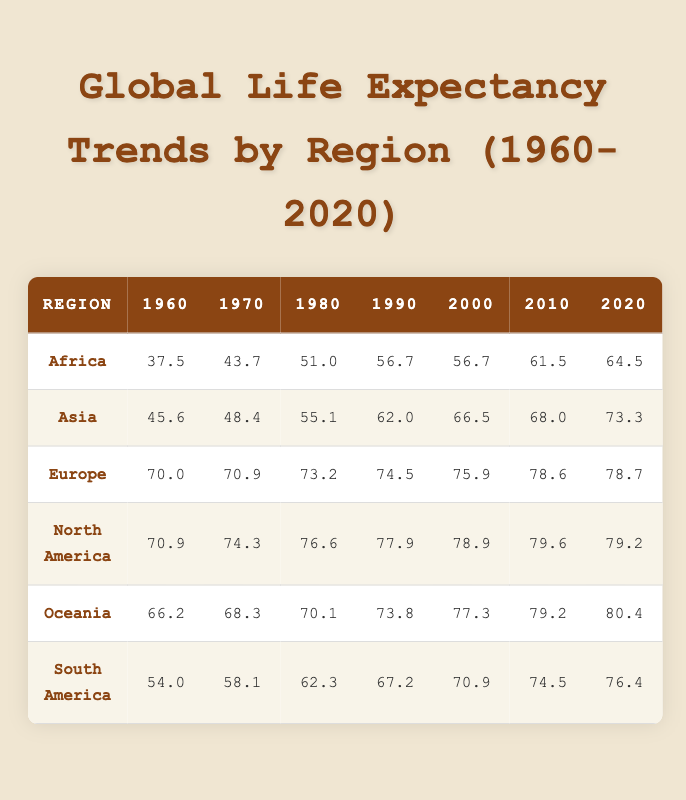What was the life expectancy in Africa in 1960? The table indicates that in 1960, the life expectancy in Africa was 37.5 years, directly available in the first column under the Africa row.
Answer: 37.5 Which region had the highest life expectancy in 1980? In 1980, the table shows that North America had the highest life expectancy at 76.6 years, which is the maximum value in that year’s row.
Answer: North America: 76.6 What is the difference in life expectancy between Europe in 1960 and Europe in 2020? Europe's life expectancy in 1960 was 70.0 years and in 2020 it was 78.7 years. The difference is 78.7 - 70.0 = 8.7 years.
Answer: 8.7 Did life expectancy in Oceania increase every decade from 1960 to 2020? Reviewing the table, Oceania had life expectancies of 66.2, 68.3, 70.1, 73.8, 77.3, 79.2, and 80.4 for the respective years. Since each value is higher than the previous one, we can conclude life expectancy increased consistently.
Answer: Yes What was the average life expectancy in Asia from 1960 to 2020? For Asia, the values are as follows: 45.6 (1960), 48.4 (1970), 55.1 (1980), 62.0 (1990), 66.5 (2000), 68.0 (2010), and 73.3 (2020). The total is 45.6 + 48.4 + 55.1 + 62.0 + 66.5 + 68.0 + 73.3 = 419.9. The average is 419.9 / 7 ≈ 59.99.
Answer: 59.99 In which year did South America first exceed a life expectancy of 70 years? The table shows that South America's life expectancy was 70.9 years in 2000, marking the first instance it exceeded 70. Prior values in 1960, 1970, 1980, and 1990 were below this threshold.
Answer: 2000 Which region showed the smallest increase in life expectancy from 2010 to 2020? In 2010, North America had a life expectancy of 79.6 years and in 2020 it was 79.2 years, indicating a decrease of 0.4 years. Meanwhile, Africa increased by 3.0 years. Therefore, North America had the smallest change.
Answer: North America How much did life expectancy in Africa improve from 1960 to 2020? The life expectancy in Africa improved from 37.5 years in 1960 to 64.5 years in 2020. The improvement is calculated as 64.5 - 37.5 = 27 years.
Answer: 27 Which three regions had a life expectancy below 60 years in 1960? Referring to the table, in 1960 the life expectancies were: Africa (37.5), Asia (45.6), and South America (54.0). All three values are below 60 years.
Answer: Africa, Asia, South America 